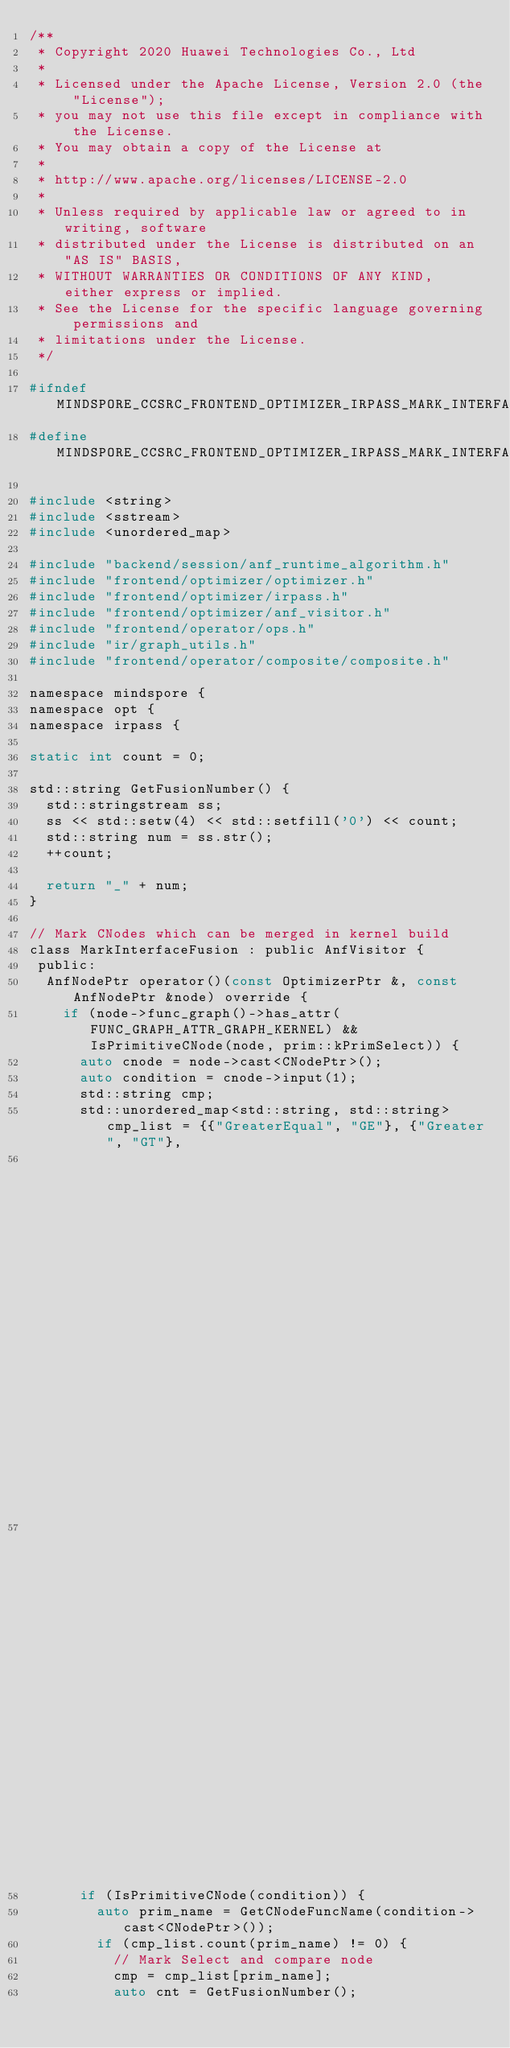Convert code to text. <code><loc_0><loc_0><loc_500><loc_500><_C_>/**
 * Copyright 2020 Huawei Technologies Co., Ltd
 *
 * Licensed under the Apache License, Version 2.0 (the "License");
 * you may not use this file except in compliance with the License.
 * You may obtain a copy of the License at
 *
 * http://www.apache.org/licenses/LICENSE-2.0
 *
 * Unless required by applicable law or agreed to in writing, software
 * distributed under the License is distributed on an "AS IS" BASIS,
 * WITHOUT WARRANTIES OR CONDITIONS OF ANY KIND, either express or implied.
 * See the License for the specific language governing permissions and
 * limitations under the License.
 */

#ifndef MINDSPORE_CCSRC_FRONTEND_OPTIMIZER_IRPASS_MARK_INTERFACE_FUSION_H
#define MINDSPORE_CCSRC_FRONTEND_OPTIMIZER_IRPASS_MARK_INTERFACE_FUSION_H

#include <string>
#include <sstream>
#include <unordered_map>

#include "backend/session/anf_runtime_algorithm.h"
#include "frontend/optimizer/optimizer.h"
#include "frontend/optimizer/irpass.h"
#include "frontend/optimizer/anf_visitor.h"
#include "frontend/operator/ops.h"
#include "ir/graph_utils.h"
#include "frontend/operator/composite/composite.h"

namespace mindspore {
namespace opt {
namespace irpass {

static int count = 0;

std::string GetFusionNumber() {
  std::stringstream ss;
  ss << std::setw(4) << std::setfill('0') << count;
  std::string num = ss.str();
  ++count;

  return "_" + num;
}

// Mark CNodes which can be merged in kernel build
class MarkInterfaceFusion : public AnfVisitor {
 public:
  AnfNodePtr operator()(const OptimizerPtr &, const AnfNodePtr &node) override {
    if (node->func_graph()->has_attr(FUNC_GRAPH_ATTR_GRAPH_KERNEL) && IsPrimitiveCNode(node, prim::kPrimSelect)) {
      auto cnode = node->cast<CNodePtr>();
      auto condition = cnode->input(1);
      std::string cmp;
      std::unordered_map<std::string, std::string> cmp_list = {{"GreaterEqual", "GE"}, {"Greater", "GT"},
                                                               {"LessEqual", "LE"},    {"Less", "LT"},
                                                               {"Equal", "EQ"},        {"NotEqual", "NE"}};
      if (IsPrimitiveCNode(condition)) {
        auto prim_name = GetCNodeFuncName(condition->cast<CNodePtr>());
        if (cmp_list.count(prim_name) != 0) {
          // Mark Select and compare node
          cmp = cmp_list[prim_name];
          auto cnt = GetFusionNumber();</code> 